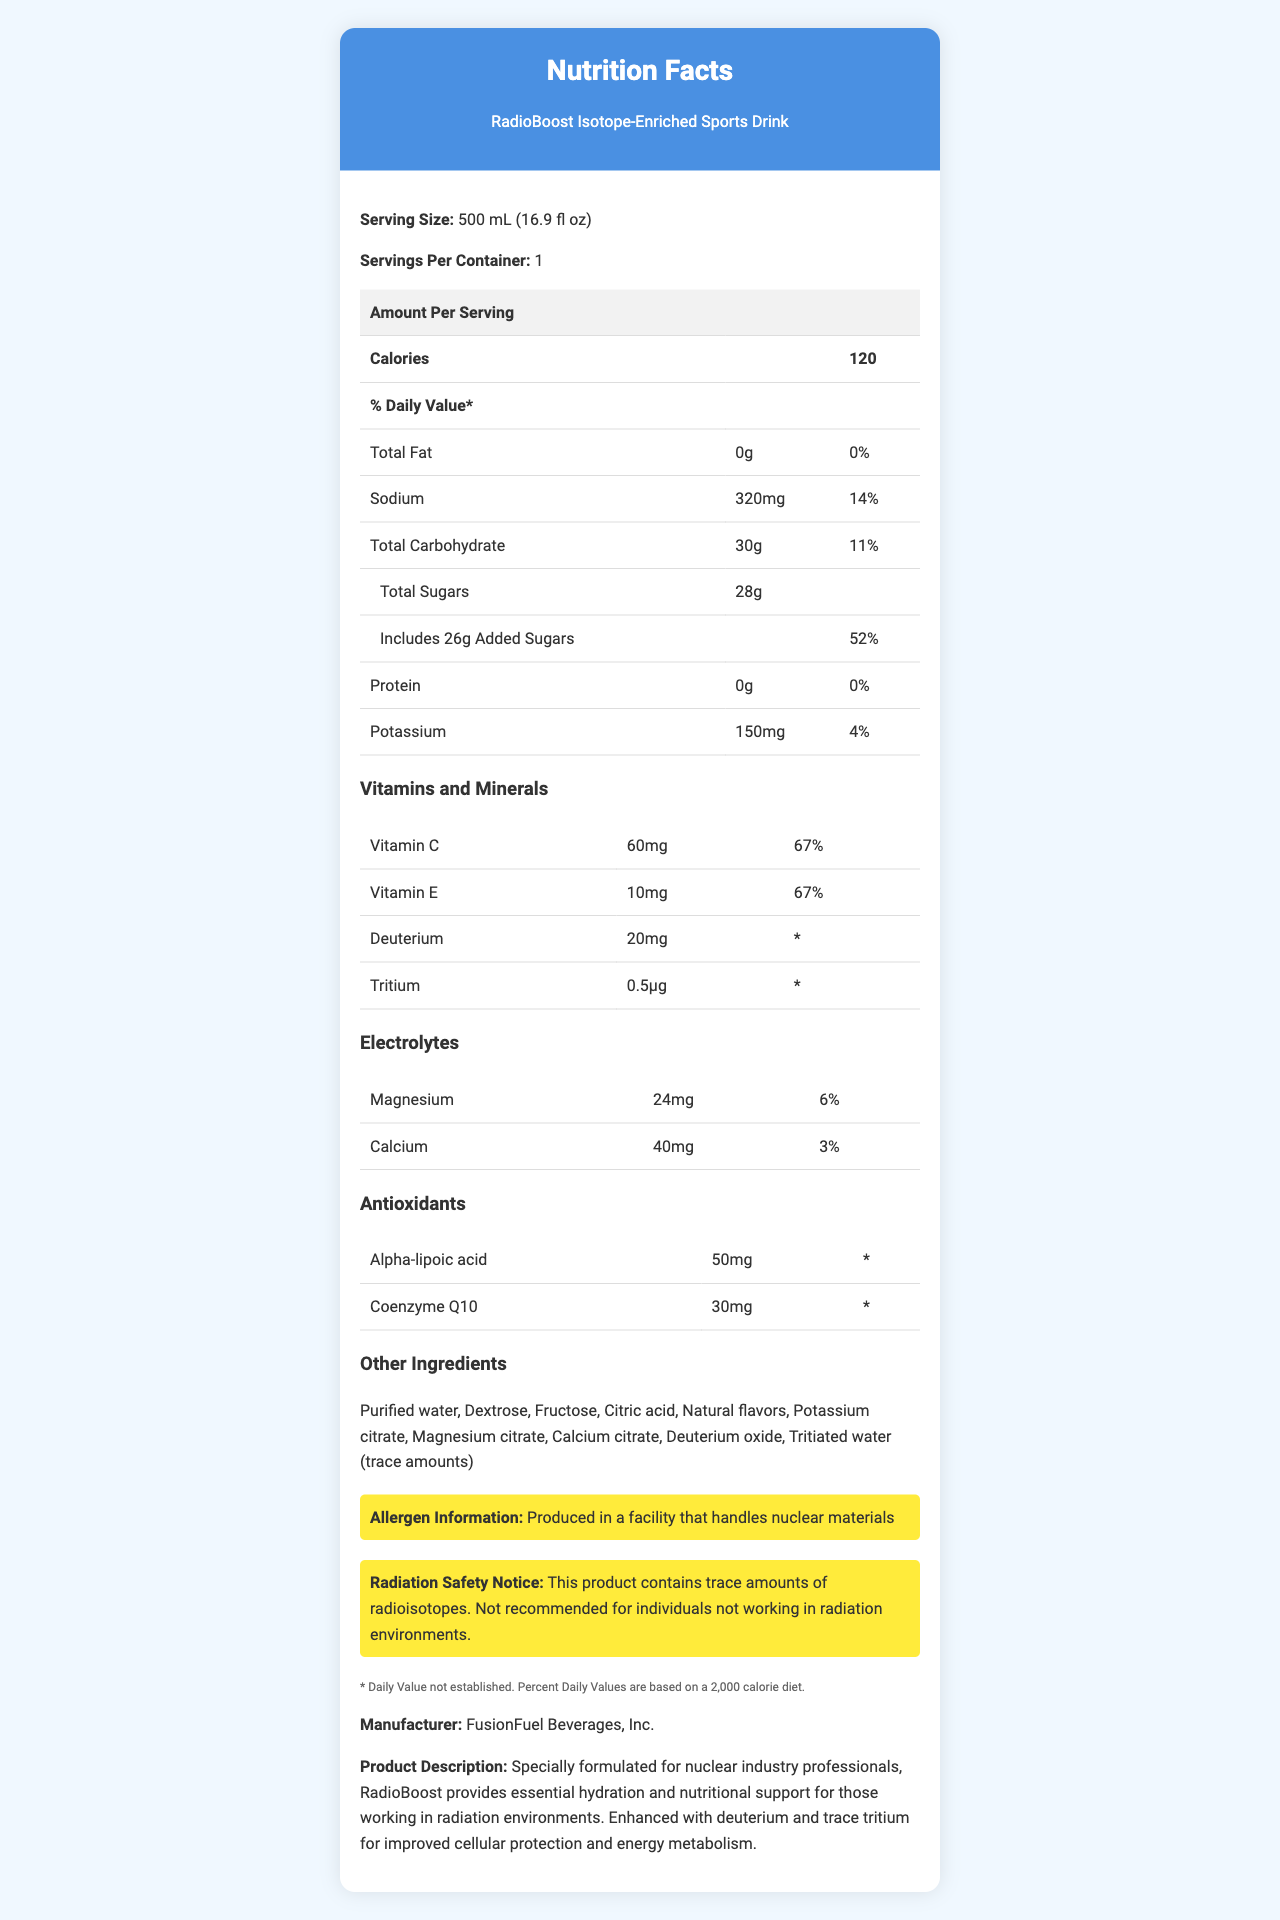what is the serving size of RadioBoost Isotope-Enriched Sports Drink? The document states that the serving size is 500 mL (16.9 fl oz).
Answer: 500 mL (16.9 fl oz) How many servings are in one container of RadioBoost Isotope-Enriched Sports Drink? The document lists one serving per container.
Answer: 1 How many calories are in one serving of RadioBoost? The document mentions that one serving contains 120 calories.
Answer: 120 What percentage of the daily value of Vitamin C is included in one serving? According to the document, the daily value for Vitamin C in one serving is 67%.
Answer: 67% What is the protein content in this sports drink? The document indicates that the amount of protein per serving is 0g.
Answer: 0g How much sodium does this drink contain? The document states that the sodium content per serving is 320mg.
Answer: 320mg What is the amount of potassium in a serving? The drink contains 150mg of potassium per serving according to the document.
Answer: 150mg Can the product be recommended for the general public? The document includes a radiation safety notice that this product is not recommended for individuals not working in radiation environments.
Answer: No Provide a brief summary of the RadioBoost Isotope-Enriched Sports Drink nutrition label. The summary captures the main nutritional components, unique isotopic ingredients, and safety notices pertinent to users in radiation work settings.
Answer: The RadioBoost Isotope-Enriched Sports Drink is designed for nuclear industry professionals, providing essential hydration and nutritional support. It contains 120 calories per 500 mL serving, includes sodium, carbohydrates, sugars, and essential vitamins and minerals, such as Vitamin C and E. Unique ingredients include isotopes like deuterium and trace amounts of tritium for improved cellular protection. The drink also contains electrolytes and antioxidants. Allergen information and radiation safety notices are provided, stressing that the product is meant for those working in radiation environments. How many grams of added sugars are in one serving? The document states that there are 26 grams of added sugars per serving.
Answer: 26g Does the document provide the daily value percentage for magnesium? The document states that the daily value of magnesium in one serving is 6%.
Answer: Yes What is the name of the manufacturer of RadioBoost? The document lists FusionFuel Beverages, Inc. as the manufacturer.
Answer: FusionFuel Beverages, Inc. How is the drink described in the document? The document includes a product description specifically mentioning its formulation for nuclear industry workers and the benefits of its enriched isotopic content.
Answer: Specially formulated for nuclear industry professionals, RadioBoost provides essential hydration and nutritional support for those working in radiation environments. Enhanced with deuterium and trace tritium for improved cellular protection and energy metabolism. How much Alpha-lipoic acid is in a serving? The document lists that a serving contains 50mg of Alpha-lipoic acid.
Answer: 50mg For what kind of diet are the percent daily values based? The document notes that the percent daily values are based on a 2,000 calorie diet.
Answer: A 2,000 calorie diet Does the label mention if artificial flavors are used? The document only mentions "Natural flavors" under other ingredients, with no mention of artificial flavors.
Answer: No 